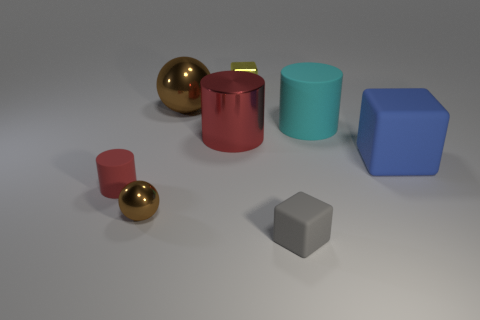Add 1 large cyan matte cylinders. How many objects exist? 9 Subtract all cubes. How many objects are left? 5 Subtract all big cyan cylinders. Subtract all gray things. How many objects are left? 6 Add 8 big red cylinders. How many big red cylinders are left? 9 Add 1 small red matte things. How many small red matte things exist? 2 Subtract 0 green cylinders. How many objects are left? 8 